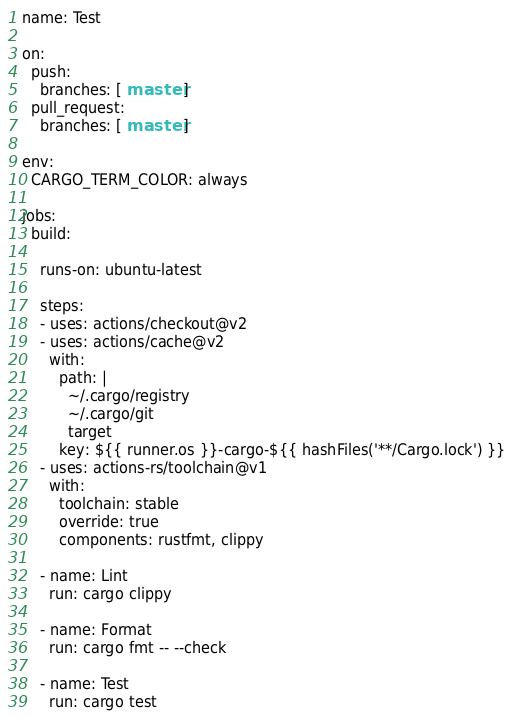Convert code to text. <code><loc_0><loc_0><loc_500><loc_500><_YAML_>name: Test

on:
  push:
    branches: [ master ]
  pull_request:
    branches: [ master ]

env:
  CARGO_TERM_COLOR: always

jobs:
  build:

    runs-on: ubuntu-latest

    steps:
    - uses: actions/checkout@v2
    - uses: actions/cache@v2
      with:
        path: |
          ~/.cargo/registry
          ~/.cargo/git
          target
        key: ${{ runner.os }}-cargo-${{ hashFiles('**/Cargo.lock') }}
    - uses: actions-rs/toolchain@v1
      with:
        toolchain: stable
        override: true
        components: rustfmt, clippy

    - name: Lint
      run: cargo clippy

    - name: Format
      run: cargo fmt -- --check

    - name: Test
      run: cargo test
</code> 